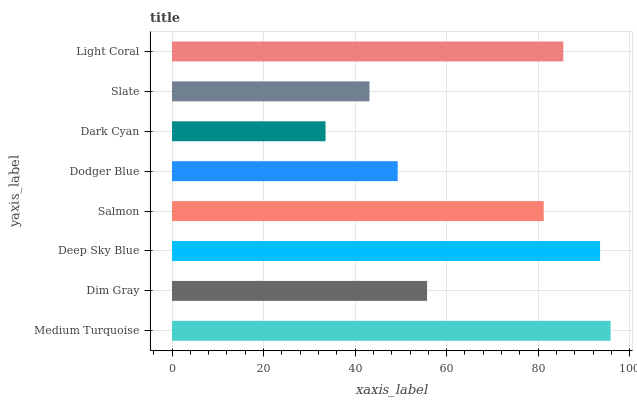Is Dark Cyan the minimum?
Answer yes or no. Yes. Is Medium Turquoise the maximum?
Answer yes or no. Yes. Is Dim Gray the minimum?
Answer yes or no. No. Is Dim Gray the maximum?
Answer yes or no. No. Is Medium Turquoise greater than Dim Gray?
Answer yes or no. Yes. Is Dim Gray less than Medium Turquoise?
Answer yes or no. Yes. Is Dim Gray greater than Medium Turquoise?
Answer yes or no. No. Is Medium Turquoise less than Dim Gray?
Answer yes or no. No. Is Salmon the high median?
Answer yes or no. Yes. Is Dim Gray the low median?
Answer yes or no. Yes. Is Medium Turquoise the high median?
Answer yes or no. No. Is Dodger Blue the low median?
Answer yes or no. No. 